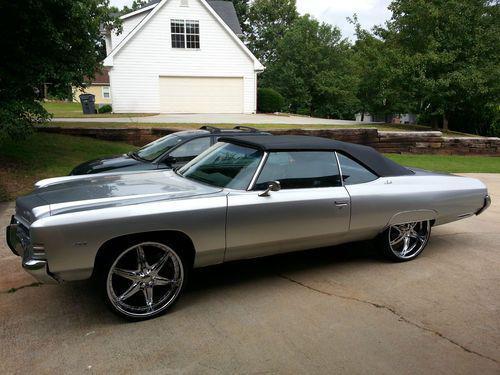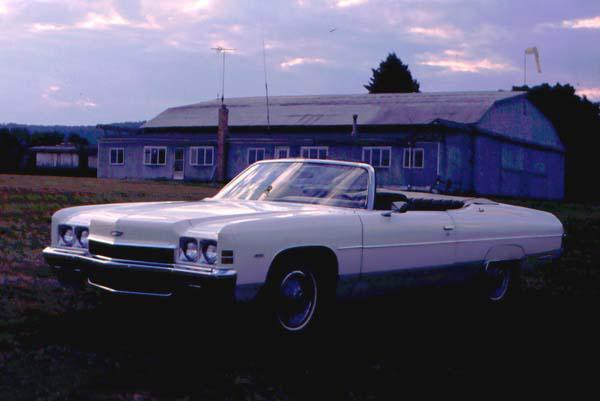The first image is the image on the left, the second image is the image on the right. Analyze the images presented: Is the assertion "One or more of the cars shown are turned to the right." valid? Answer yes or no. No. The first image is the image on the left, the second image is the image on the right. Examine the images to the left and right. Is the description "An image shows a convertible car covered with a dark top." accurate? Answer yes or no. Yes. 